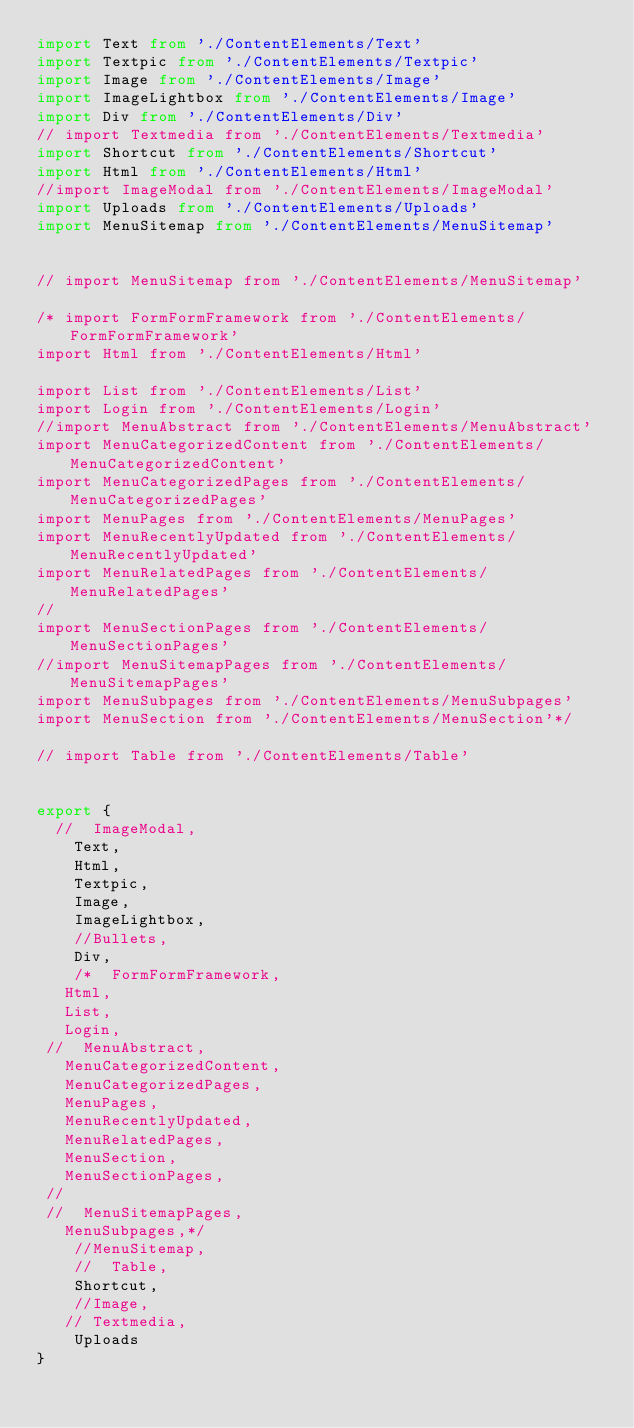<code> <loc_0><loc_0><loc_500><loc_500><_TypeScript_>import Text from './ContentElements/Text'
import Textpic from './ContentElements/Textpic'
import Image from './ContentElements/Image'
import ImageLightbox from './ContentElements/Image'
import Div from './ContentElements/Div'
// import Textmedia from './ContentElements/Textmedia'
import Shortcut from './ContentElements/Shortcut'
import Html from './ContentElements/Html'
//import ImageModal from './ContentElements/ImageModal'
import Uploads from './ContentElements/Uploads'
import MenuSitemap from './ContentElements/MenuSitemap'


// import MenuSitemap from './ContentElements/MenuSitemap'

/* import FormFormFramework from './ContentElements/FormFormFramework'
import Html from './ContentElements/Html'

import List from './ContentElements/List'
import Login from './ContentElements/Login'
//import MenuAbstract from './ContentElements/MenuAbstract'
import MenuCategorizedContent from './ContentElements/MenuCategorizedContent'
import MenuCategorizedPages from './ContentElements/MenuCategorizedPages'
import MenuPages from './ContentElements/MenuPages'
import MenuRecentlyUpdated from './ContentElements/MenuRecentlyUpdated'
import MenuRelatedPages from './ContentElements/MenuRelatedPages'
//
import MenuSectionPages from './ContentElements/MenuSectionPages'
//import MenuSitemapPages from './ContentElements/MenuSitemapPages'
import MenuSubpages from './ContentElements/MenuSubpages'
import MenuSection from './ContentElements/MenuSection'*/

// import Table from './ContentElements/Table'


export {
  //  ImageModal,
    Text,
    Html,
    Textpic,
    Image,
    ImageLightbox,
    //Bullets,
    Div,
    /*  FormFormFramework,
   Html,
   List,
   Login,
 //  MenuAbstract,
   MenuCategorizedContent,
   MenuCategorizedPages,
   MenuPages,
   MenuRecentlyUpdated,
   MenuRelatedPages,
   MenuSection,
   MenuSectionPages,
 //
 //  MenuSitemapPages,
   MenuSubpages,*/
    //MenuSitemap,
    //  Table,
    Shortcut,
    //Image,
   // Textmedia,
    Uploads
}
</code> 